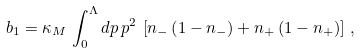<formula> <loc_0><loc_0><loc_500><loc_500>b _ { 1 } = \kappa _ { M } \, \int _ { 0 } ^ { \Lambda } d p \, p ^ { 2 } \, \left [ n _ { - } \left ( 1 - n _ { - } \right ) + n _ { + } \left ( 1 - n _ { + } \right ) \right ] \, ,</formula> 